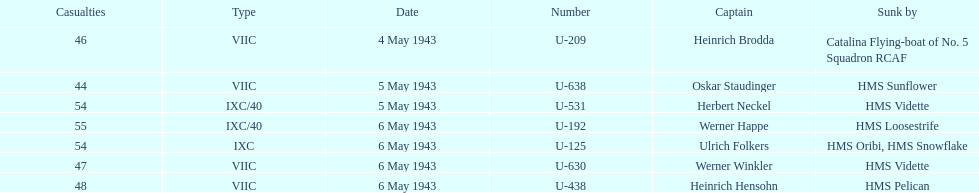Which sunken u-boat had the most casualties U-192. 